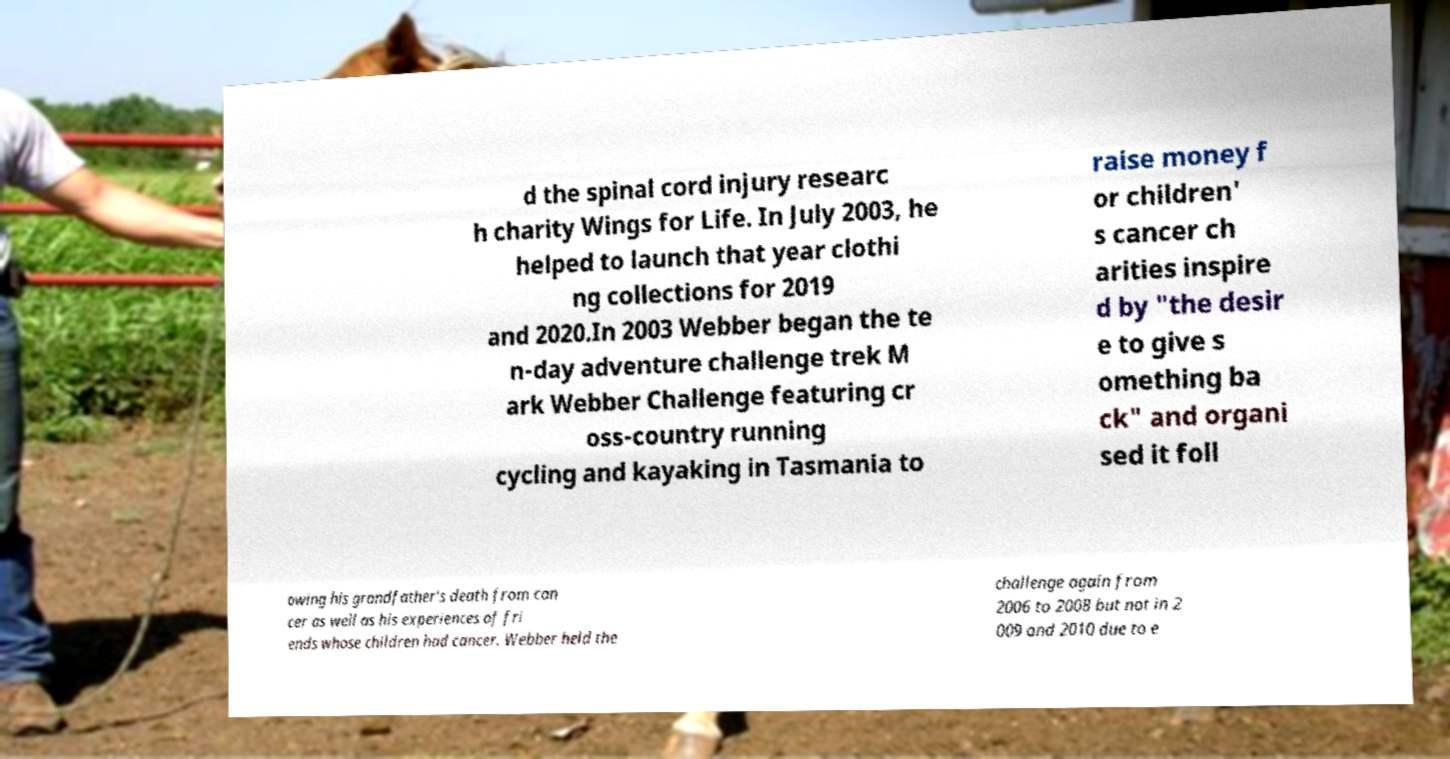Can you read and provide the text displayed in the image?This photo seems to have some interesting text. Can you extract and type it out for me? d the spinal cord injury researc h charity Wings for Life. In July 2003, he helped to launch that year clothi ng collections for 2019 and 2020.In 2003 Webber began the te n-day adventure challenge trek M ark Webber Challenge featuring cr oss-country running cycling and kayaking in Tasmania to raise money f or children' s cancer ch arities inspire d by "the desir e to give s omething ba ck" and organi sed it foll owing his grandfather's death from can cer as well as his experiences of fri ends whose children had cancer. Webber held the challenge again from 2006 to 2008 but not in 2 009 and 2010 due to e 